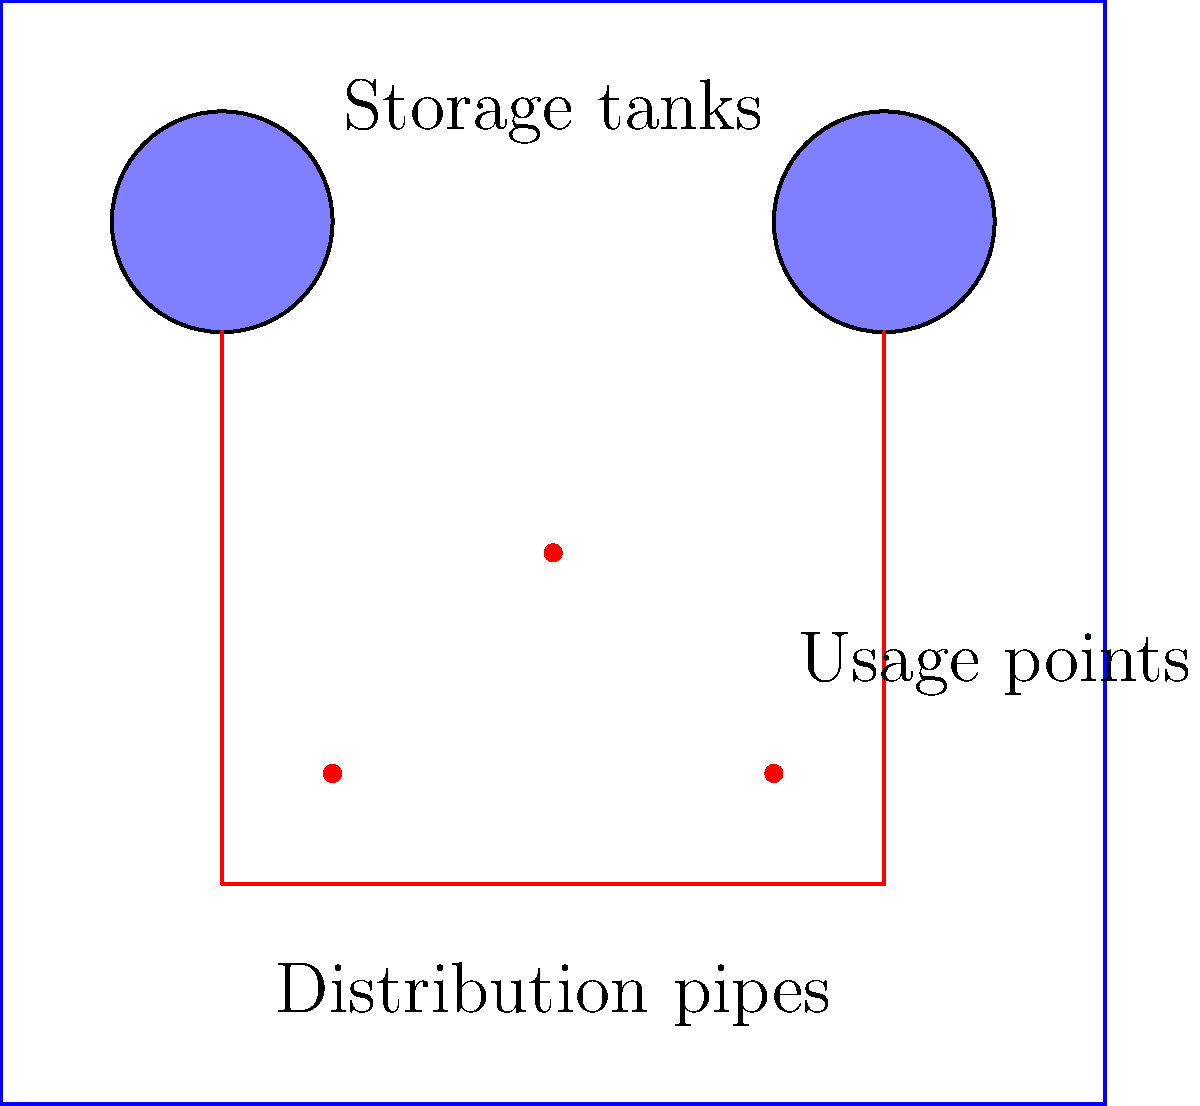As the lead guitarist planning a three-day outdoor music festival, you're tasked with estimating the water requirements. The site can accommodate 50,000 fans per day, and each person is estimated to use 15 liters of water daily. If the two on-site storage tanks can hold a total of 1,500,000 liters, how many times will they need to be refilled during the festival to meet the demand? Let's break this down step-by-step:

1. Calculate the daily water requirement:
   $50,000 \text{ fans} \times 15 \text{ L/person} = 750,000 \text{ L/day}$

2. Calculate the total water requirement for the 3-day festival:
   $750,000 \text{ L/day} \times 3 \text{ days} = 2,250,000 \text{ L}$

3. Calculate the number of times the tanks need to be filled:
   $\text{Number of fills} = \frac{\text{Total water required}}{\text{Tank capacity}}$
   $\text{Number of fills} = \frac{2,250,000 \text{ L}}{1,500,000 \text{ L}} = 1.5$

4. Since we can only fill tanks a whole number of times, we need to round up to 2 fills.

5. However, the question asks how many times they need to be refilled. The initial fill doesn't count as a refill, so we subtract 1.

Therefore, the tanks will need to be refilled once during the festival.
Answer: 1 time 